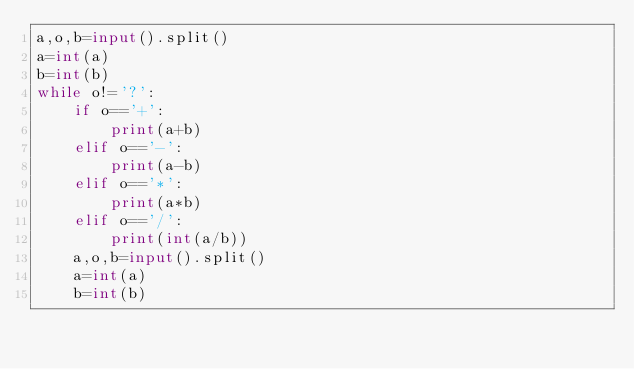<code> <loc_0><loc_0><loc_500><loc_500><_Python_>a,o,b=input().split()
a=int(a)
b=int(b)
while o!='?':
    if o=='+':
        print(a+b)
    elif o=='-':
        print(a-b)
    elif o=='*':
        print(a*b)
    elif o=='/':
        print(int(a/b))
    a,o,b=input().split()
    a=int(a)
    b=int(b)
</code> 